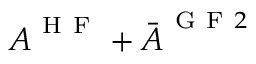Convert formula to latex. <formula><loc_0><loc_0><loc_500><loc_500>A ^ { H F } + \ B a r { A } ^ { G F 2 }</formula> 